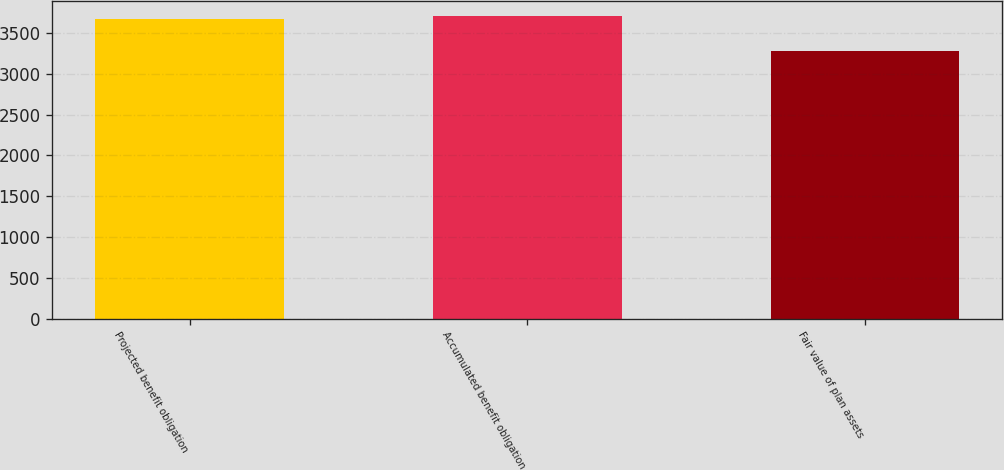Convert chart to OTSL. <chart><loc_0><loc_0><loc_500><loc_500><bar_chart><fcel>Projected benefit obligation<fcel>Accumulated benefit obligation<fcel>Fair value of plan assets<nl><fcel>3669<fcel>3707.7<fcel>3282<nl></chart> 